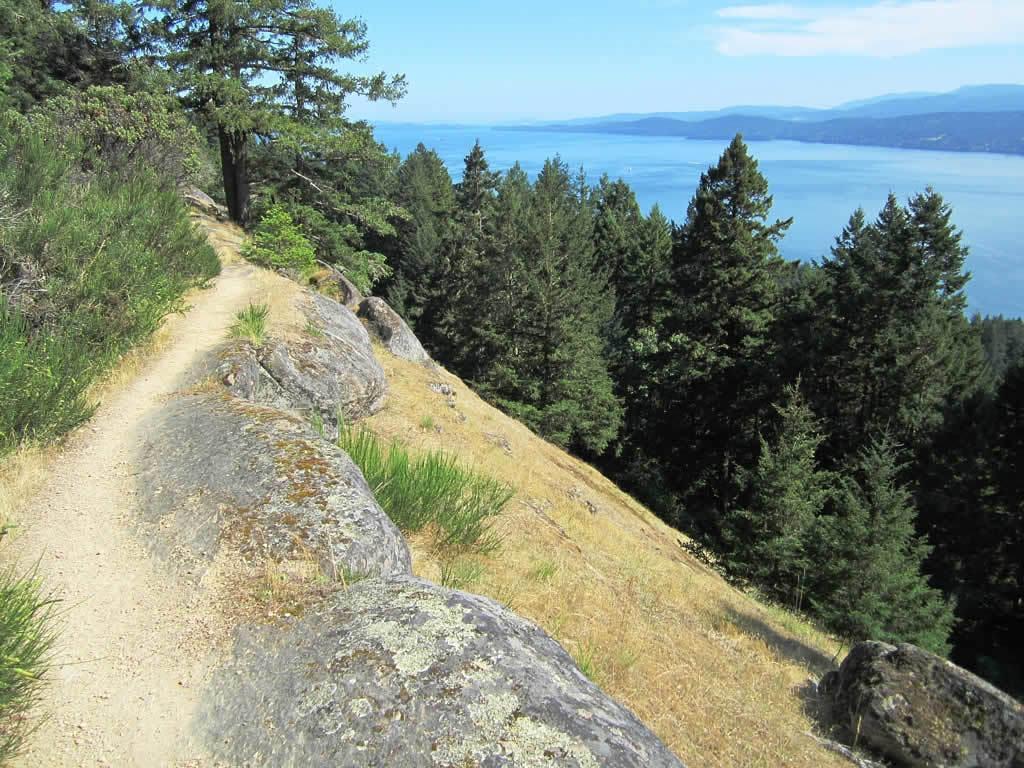Can you describe this image briefly? In the foreground of this image, there is the path on the cliff. On either sides, there are trees and grass. In middle, there are stones. In the background, there is water, mountain, sky and the cloud. 